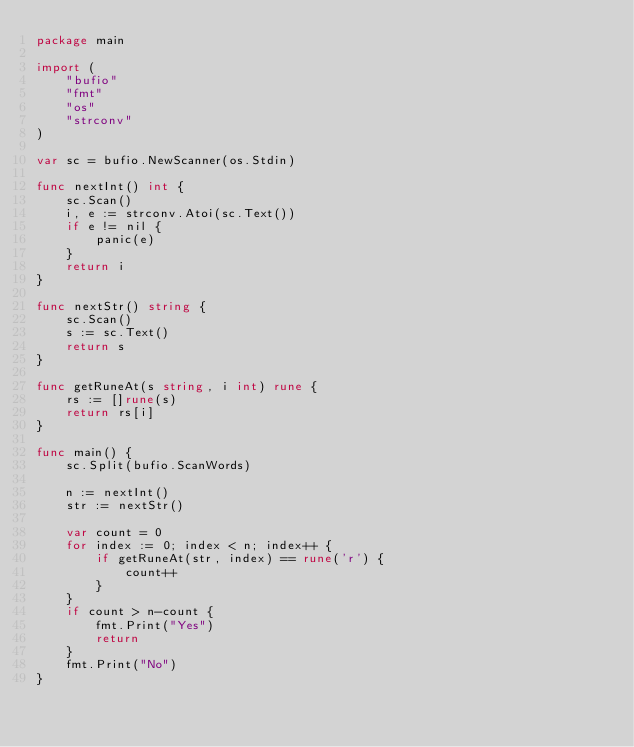Convert code to text. <code><loc_0><loc_0><loc_500><loc_500><_Go_>package main

import (
	"bufio"
	"fmt"
	"os"
	"strconv"
)

var sc = bufio.NewScanner(os.Stdin)

func nextInt() int {
	sc.Scan()
	i, e := strconv.Atoi(sc.Text())
	if e != nil {
		panic(e)
	}
	return i
}

func nextStr() string {
	sc.Scan()
	s := sc.Text()
	return s
}

func getRuneAt(s string, i int) rune {
	rs := []rune(s)
	return rs[i]
}

func main() {
	sc.Split(bufio.ScanWords)

	n := nextInt()
	str := nextStr()

	var count = 0
	for index := 0; index < n; index++ {
		if getRuneAt(str, index) == rune('r') {
			count++
		}
	}
	if count > n-count {
		fmt.Print("Yes")
		return
	}
	fmt.Print("No")
}</code> 